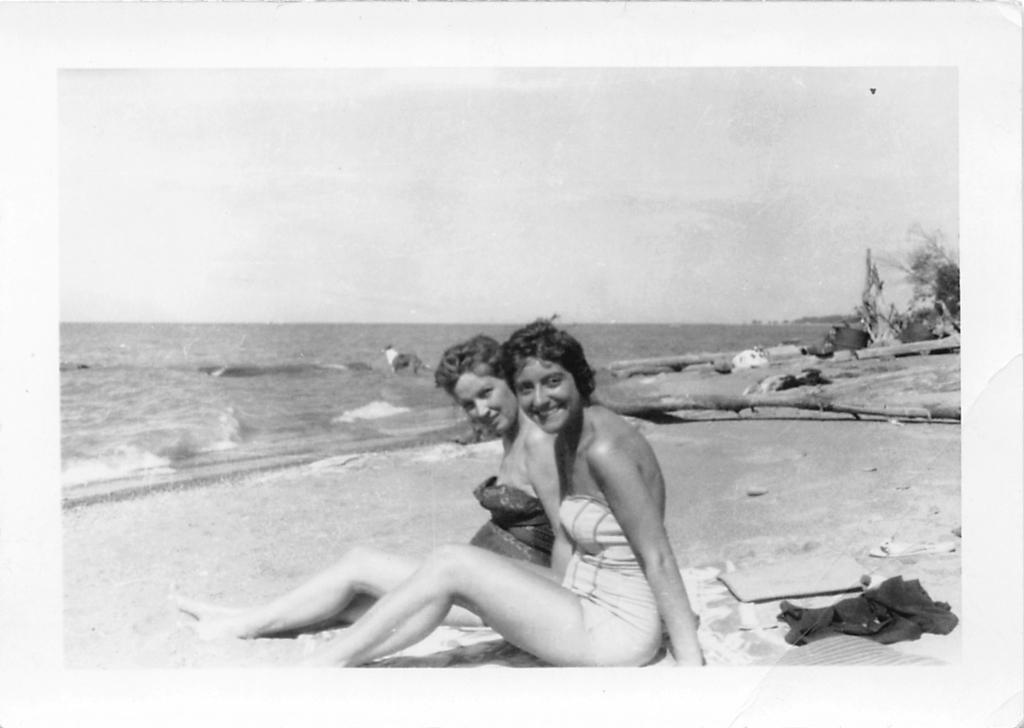How would you summarize this image in a sentence or two? In this image we can see two lady persons wearing bikini sitting at the seashore and at the background of the image there are some trees, water and clear sky. 